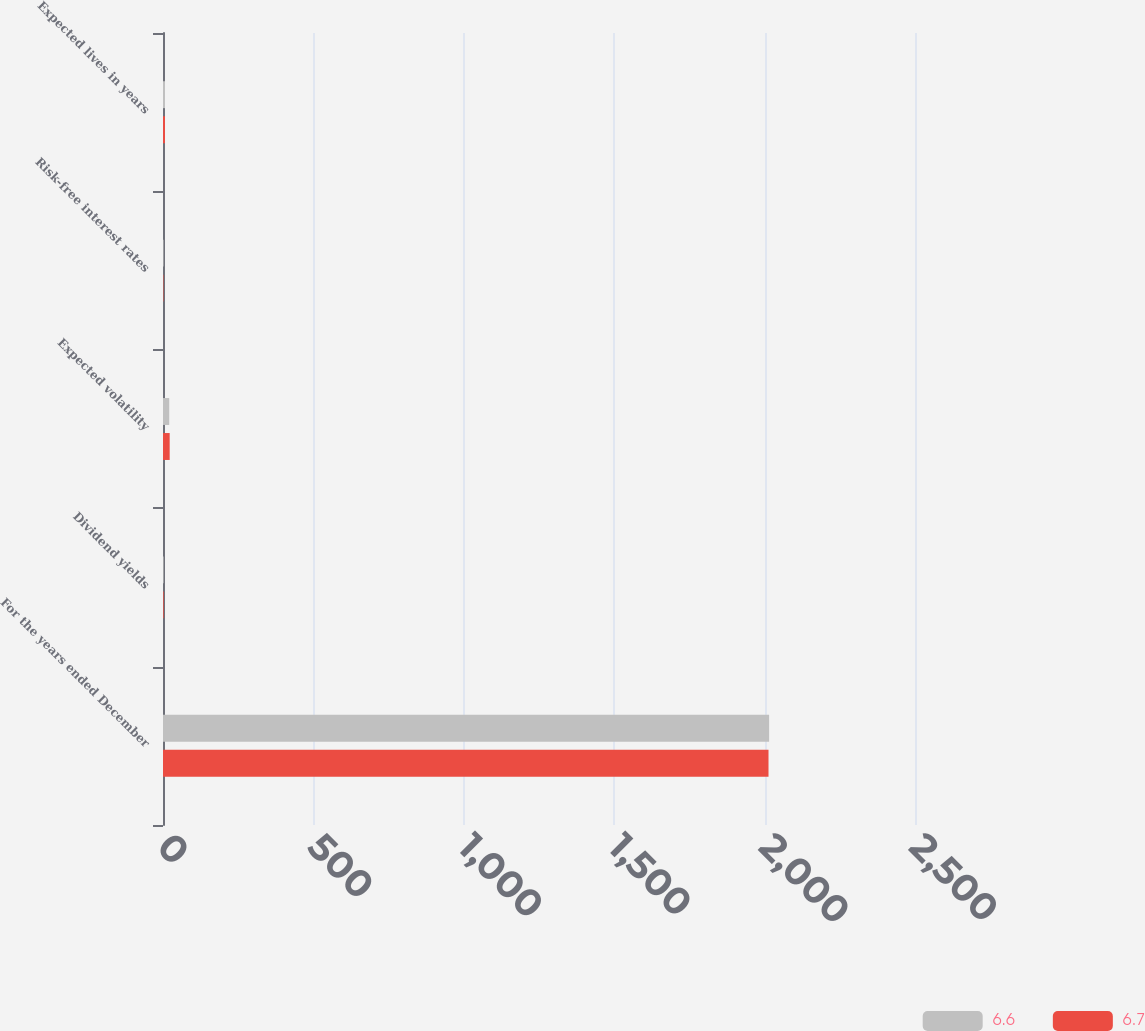Convert chart. <chart><loc_0><loc_0><loc_500><loc_500><stacked_bar_chart><ecel><fcel>For the years ended December<fcel>Dividend yields<fcel>Expected volatility<fcel>Risk-free interest rates<fcel>Expected lives in years<nl><fcel>6.6<fcel>2015<fcel>2.1<fcel>20.7<fcel>1.9<fcel>6.7<nl><fcel>6.7<fcel>2013<fcel>2.2<fcel>22.2<fcel>1.4<fcel>6.6<nl></chart> 